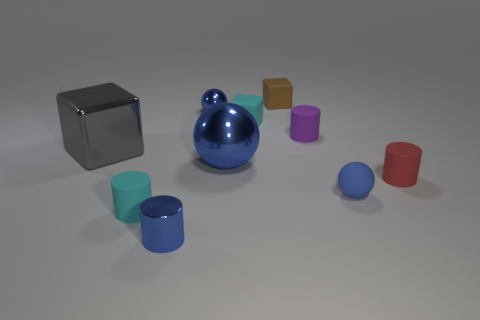What is the large sphere made of?
Make the answer very short. Metal. There is a small metal object behind the tiny purple cylinder; does it have the same color as the small metallic thing in front of the red thing?
Provide a short and direct response. Yes. Are there more tiny blue metal cylinders than small blocks?
Provide a short and direct response. No. How many other tiny metallic cylinders have the same color as the tiny metallic cylinder?
Offer a very short reply. 0. There is another small object that is the same shape as the tiny brown object; what color is it?
Keep it short and to the point. Cyan. The object that is both in front of the tiny red object and to the left of the small shiny cylinder is made of what material?
Provide a succinct answer. Rubber. Is the small red object that is in front of the purple cylinder made of the same material as the small blue ball that is to the left of the cyan rubber block?
Your answer should be very brief. No. The gray metallic thing is what size?
Offer a terse response. Large. What is the size of the shiny thing that is the same shape as the brown rubber thing?
Your response must be concise. Large. What number of tiny blue objects are in front of the brown cube?
Your response must be concise. 3. 